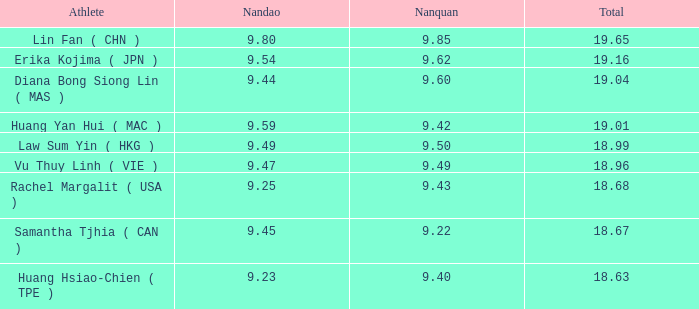Which Nanquan has a Nandao smaller than 9.44, and a Rank smaller than 9, and a Total larger than 18.68? None. Parse the table in full. {'header': ['Athlete', 'Nandao', 'Nanquan', 'Total'], 'rows': [['Lin Fan ( CHN )', '9.80', '9.85', '19.65'], ['Erika Kojima ( JPN )', '9.54', '9.62', '19.16'], ['Diana Bong Siong Lin ( MAS )', '9.44', '9.60', '19.04'], ['Huang Yan Hui ( MAC )', '9.59', '9.42', '19.01'], ['Law Sum Yin ( HKG )', '9.49', '9.50', '18.99'], ['Vu Thuy Linh ( VIE )', '9.47', '9.49', '18.96'], ['Rachel Margalit ( USA )', '9.25', '9.43', '18.68'], ['Samantha Tjhia ( CAN )', '9.45', '9.22', '18.67'], ['Huang Hsiao-Chien ( TPE )', '9.23', '9.40', '18.63']]} 